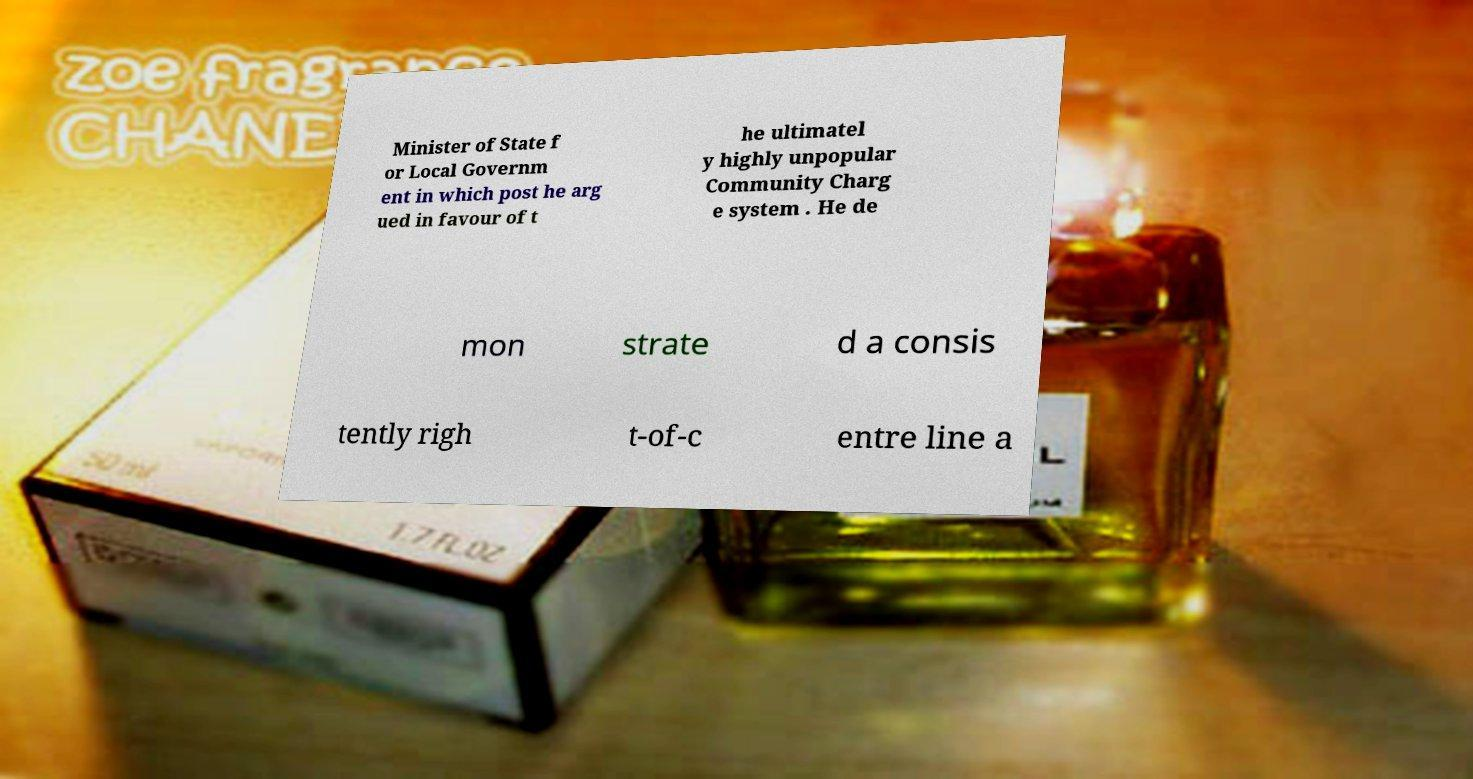What messages or text are displayed in this image? I need them in a readable, typed format. Minister of State f or Local Governm ent in which post he arg ued in favour of t he ultimatel y highly unpopular Community Charg e system . He de mon strate d a consis tently righ t-of-c entre line a 